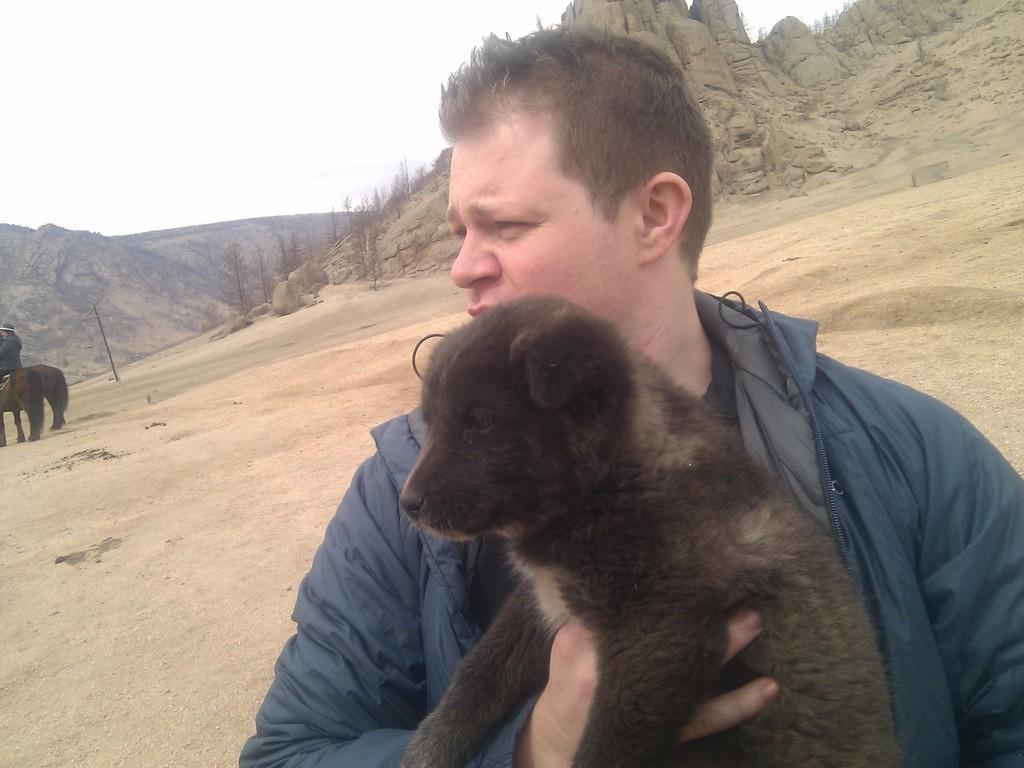Could you give a brief overview of what you see in this image? This is an empty land, here is a hill ,there is a person who is wearing blue coat, he is looking somewhere, he is holding a black color dog in his left hand in the background there is a sky, a hill. There are two horses, on the first horse there is some person sitting. 